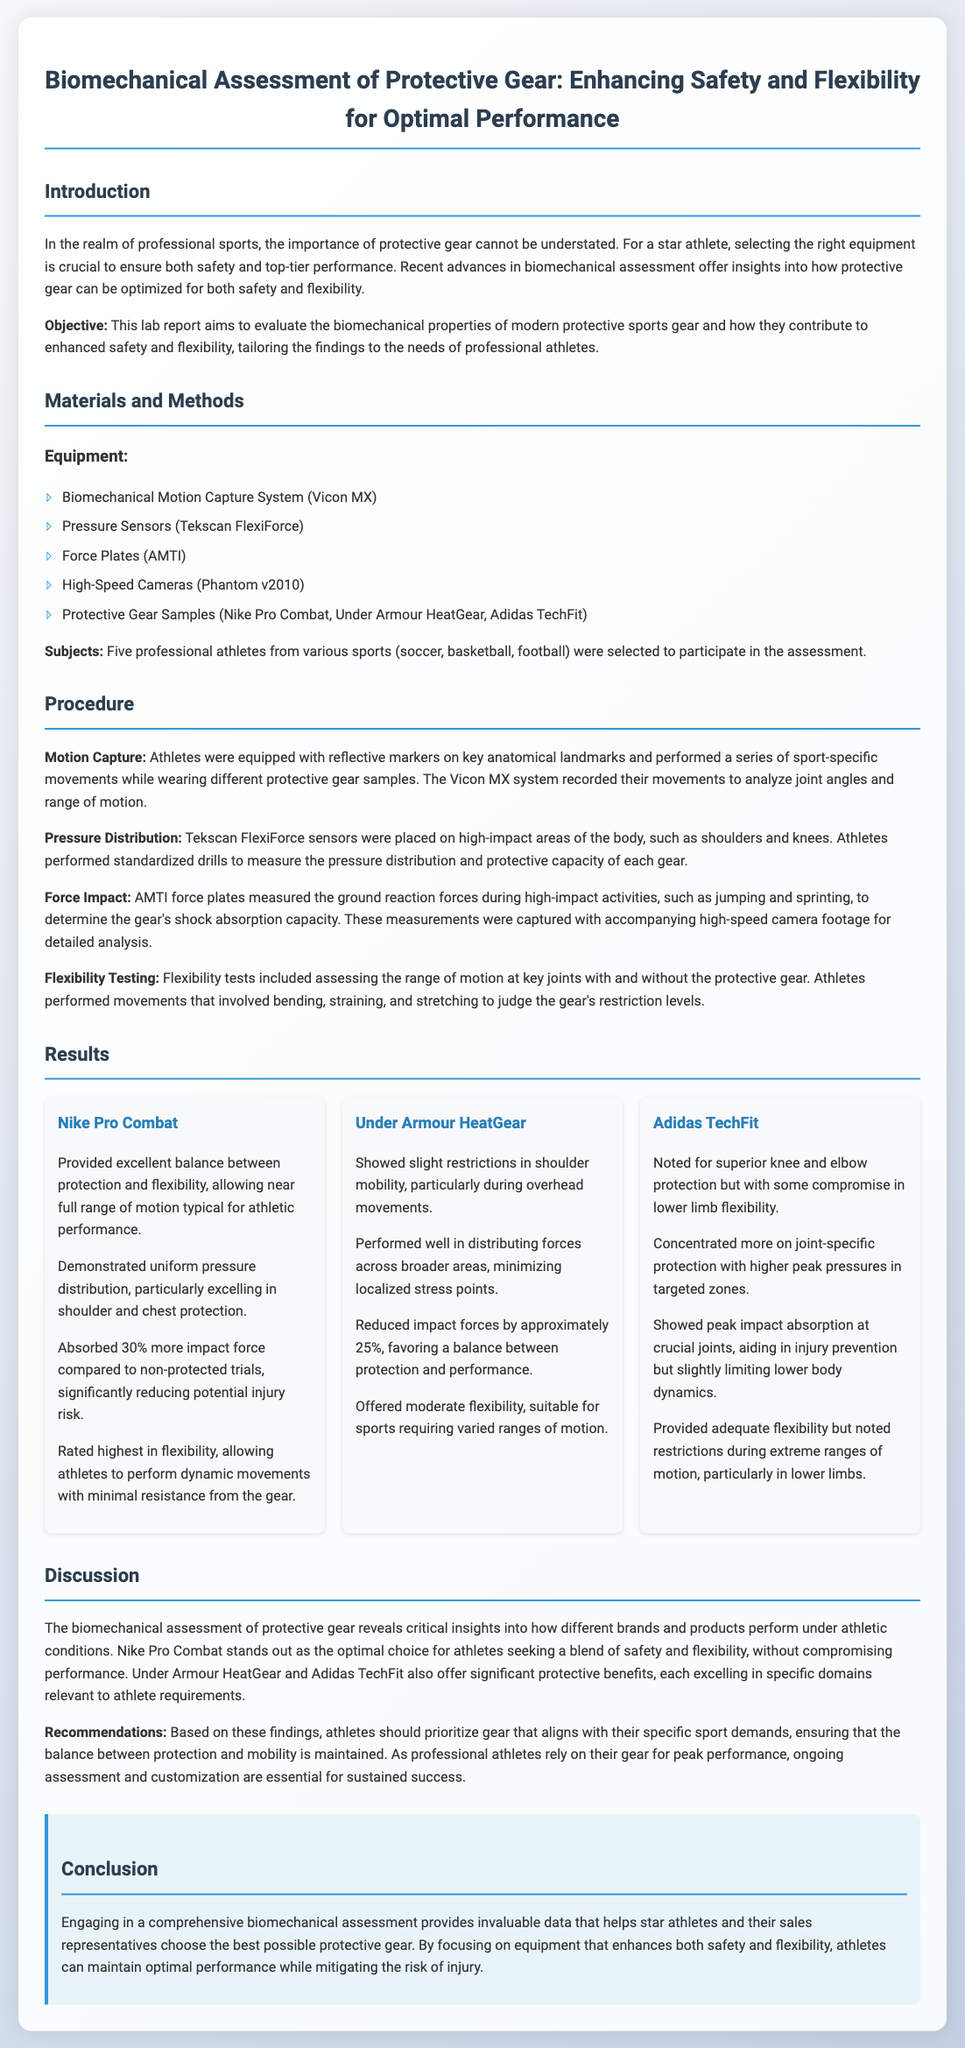What is the title of the lab report? The title summarizes the focus of the study, emphasizing biomechanical assessment and its role in protective gear for athletes.
Answer: Biomechanical Assessment of Protective Gear: Enhancing Safety and Flexibility for Optimal Performance What equipment was used for motion capture? The document lists specific equipment essential for the biomechanical assessment processes, including the motion capture system mentioned.
Answer: Vicon MX Which protective gear sample showed the best balance between protection and flexibility? The results section evaluates the performance of each gear, highlighting the one that offered the best overall benefits for athletes.
Answer: Nike Pro Combat How much more impact force did Nike Pro Combat absorb compared to non-protected trials? This numerical value indicates the gear's effectiveness in reducing the risk of injury based on collected data.
Answer: 30% What was one of the specific testing methods used in the assessment? The procedure outlines various methods employed to measure the performance of the protective gear, focusing on motion and pressure.
Answer: Pressure Distribution What specific feature did Adidas TechFit prioritize? The results discuss the strengths of each gear sample, including what Adidas TechFit excelled in, related to athlete safety.
Answer: Superior knee and elbow protection Which gear showed slight restrictions in shoulder mobility? The evaluation provides insights into how each protective gear affects mobility, pointing out any limitations observed.
Answer: Under Armour HeatGear What sport disciplines did the subjects come from? This information gives context to the study and the diverse backgrounds of the athletes included in the assessment.
Answer: Soccer, basketball, football What is the overall aim of the lab report? The objective is clearly defined in the introduction, giving an overview of the report's purpose.
Answer: Evaluate the biomechanical properties of modern protective sports gear 